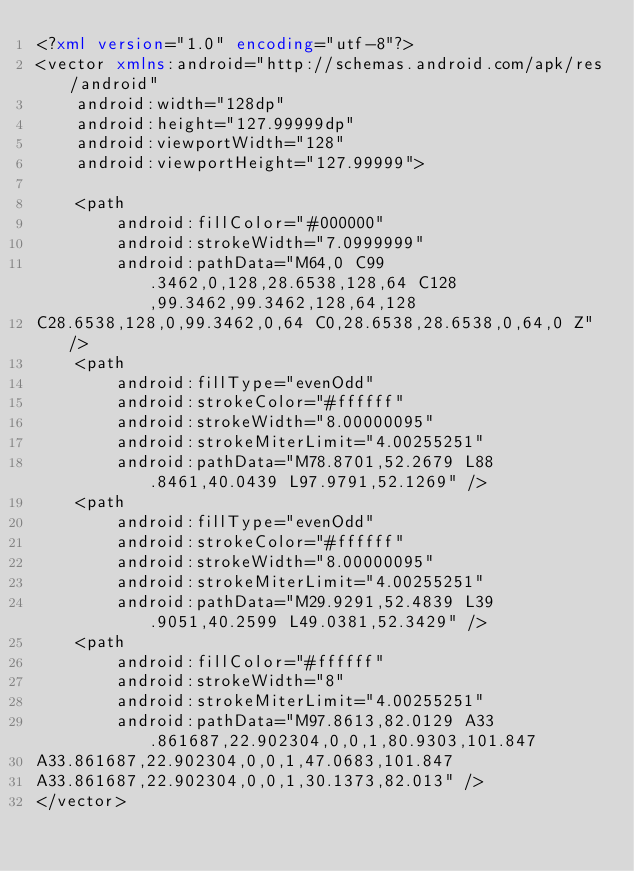Convert code to text. <code><loc_0><loc_0><loc_500><loc_500><_XML_><?xml version="1.0" encoding="utf-8"?>
<vector xmlns:android="http://schemas.android.com/apk/res/android"
    android:width="128dp"
    android:height="127.99999dp"
    android:viewportWidth="128"
    android:viewportHeight="127.99999">

    <path
        android:fillColor="#000000"
        android:strokeWidth="7.0999999"
        android:pathData="M64,0 C99.3462,0,128,28.6538,128,64 C128,99.3462,99.3462,128,64,128
C28.6538,128,0,99.3462,0,64 C0,28.6538,28.6538,0,64,0 Z" />
    <path
        android:fillType="evenOdd"
        android:strokeColor="#ffffff"
        android:strokeWidth="8.00000095"
        android:strokeMiterLimit="4.00255251"
        android:pathData="M78.8701,52.2679 L88.8461,40.0439 L97.9791,52.1269" />
    <path
        android:fillType="evenOdd"
        android:strokeColor="#ffffff"
        android:strokeWidth="8.00000095"
        android:strokeMiterLimit="4.00255251"
        android:pathData="M29.9291,52.4839 L39.9051,40.2599 L49.0381,52.3429" />
    <path
        android:fillColor="#ffffff"
        android:strokeWidth="8"
        android:strokeMiterLimit="4.00255251"
        android:pathData="M97.8613,82.0129 A33.861687,22.902304,0,0,1,80.9303,101.847
A33.861687,22.902304,0,0,1,47.0683,101.847
A33.861687,22.902304,0,0,1,30.1373,82.013" />
</vector></code> 